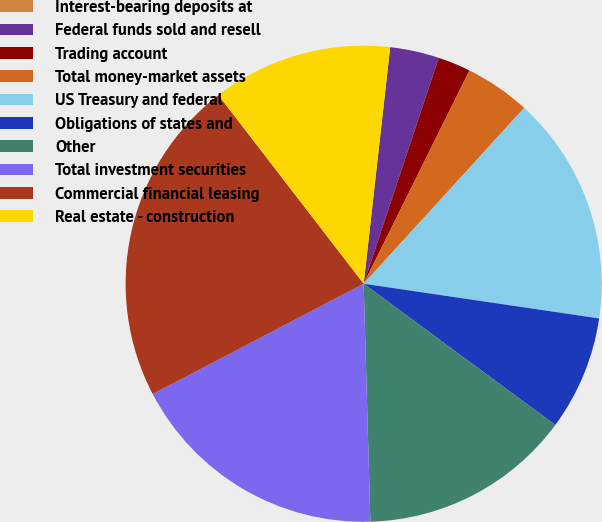<chart> <loc_0><loc_0><loc_500><loc_500><pie_chart><fcel>Interest-bearing deposits at<fcel>Federal funds sold and resell<fcel>Trading account<fcel>Total money-market assets<fcel>US Treasury and federal<fcel>Obligations of states and<fcel>Other<fcel>Total investment securities<fcel>Commercial financial leasing<fcel>Real estate - construction<nl><fcel>0.0%<fcel>3.33%<fcel>2.22%<fcel>4.45%<fcel>15.55%<fcel>7.78%<fcel>14.44%<fcel>17.78%<fcel>22.22%<fcel>12.22%<nl></chart> 